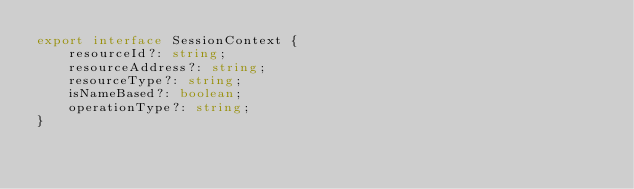<code> <loc_0><loc_0><loc_500><loc_500><_TypeScript_>export interface SessionContext {
    resourceId?: string;
    resourceAddress?: string;
    resourceType?: string;
    isNameBased?: boolean;
    operationType?: string;
}
</code> 